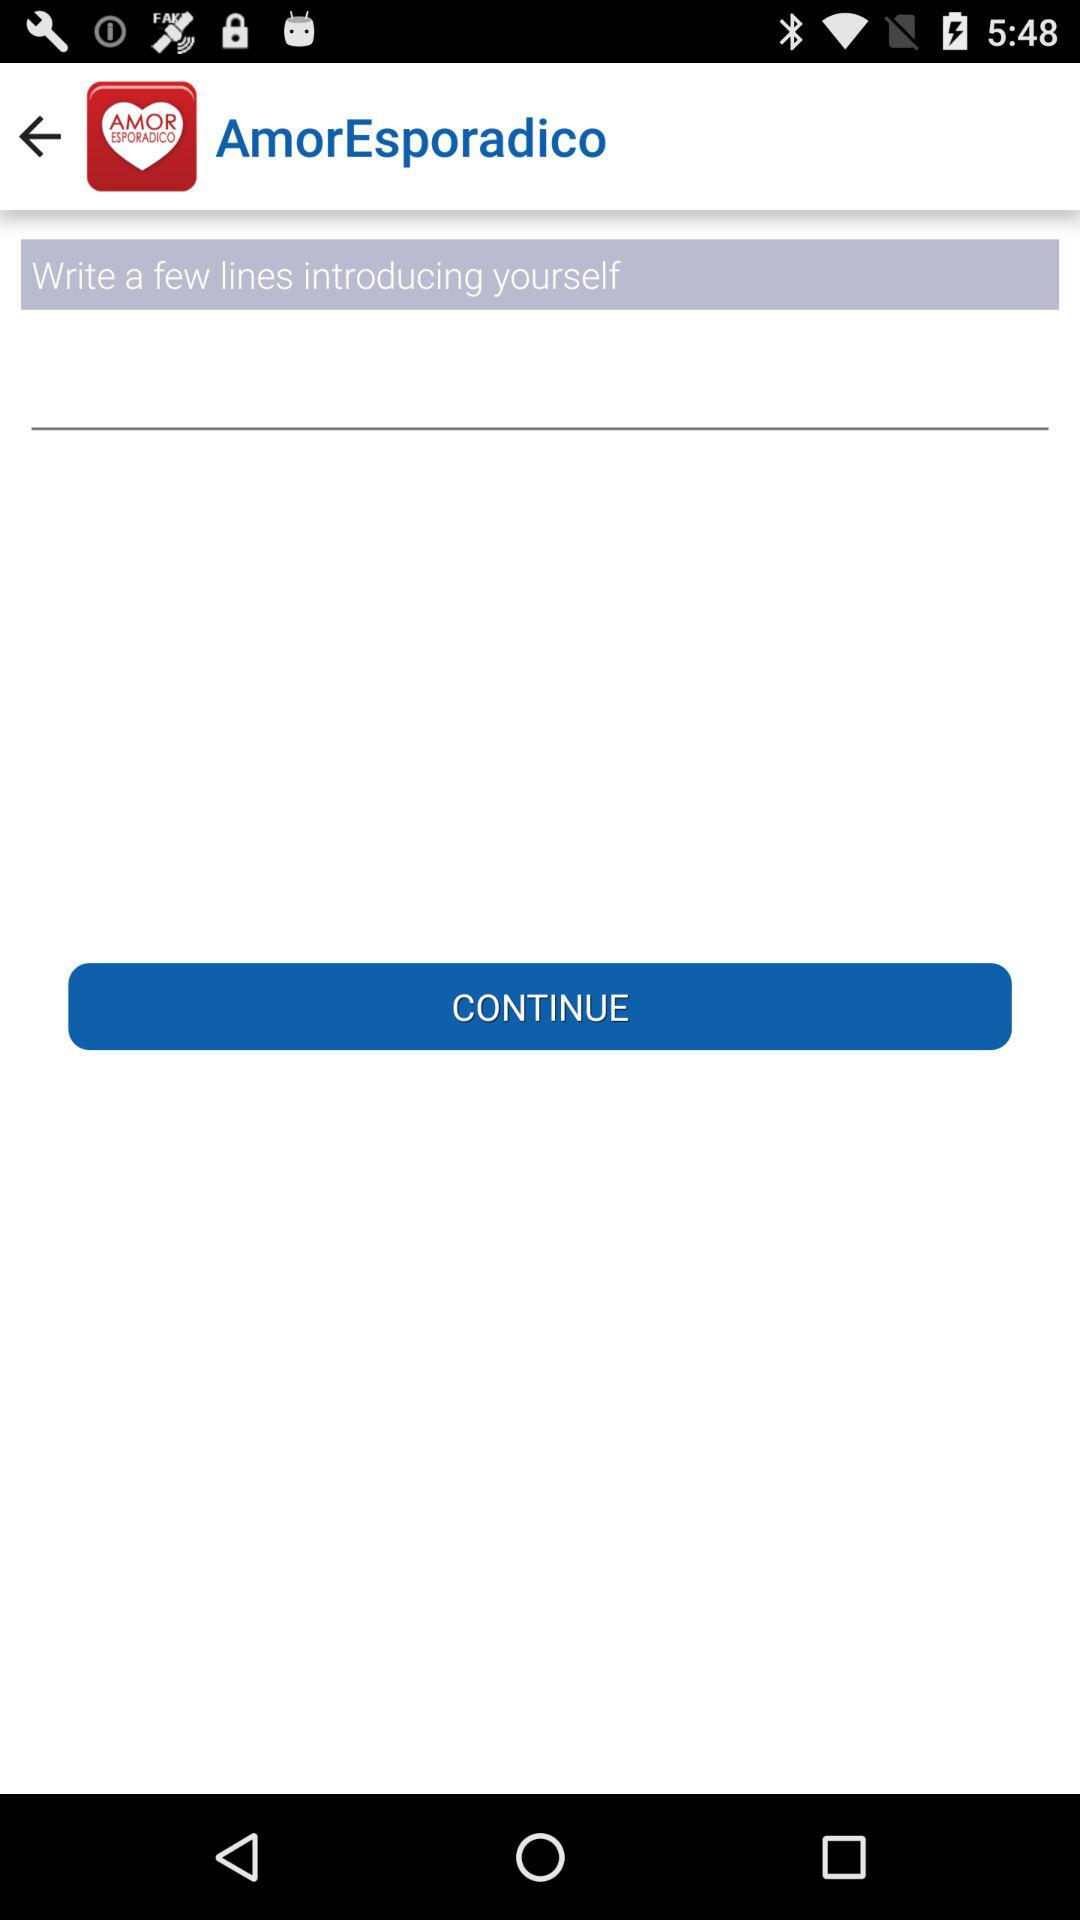What is the name of the application? The name of the application is "AmorEsporadico". 